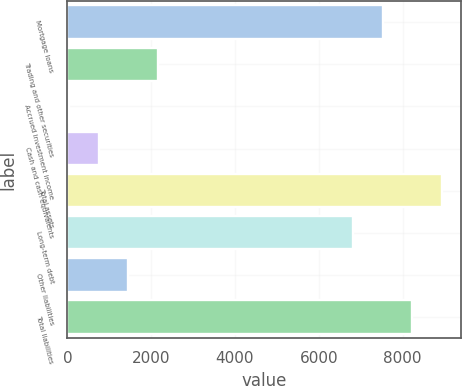<chart> <loc_0><loc_0><loc_500><loc_500><bar_chart><fcel>Mortgage loans<fcel>Trading and other securities<fcel>Accrued investment income<fcel>Cash and cash equivalents<fcel>Total assets<fcel>Long-term debt<fcel>Other liabilities<fcel>Total liabilities<nl><fcel>7528<fcel>2158<fcel>34<fcel>742<fcel>8944<fcel>6820<fcel>1450<fcel>8236<nl></chart> 